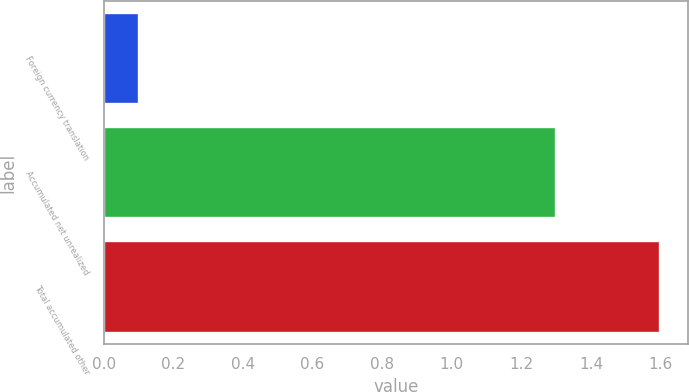Convert chart to OTSL. <chart><loc_0><loc_0><loc_500><loc_500><bar_chart><fcel>Foreign currency translation<fcel>Accumulated net unrealized<fcel>Total accumulated other<nl><fcel>0.1<fcel>1.3<fcel>1.6<nl></chart> 